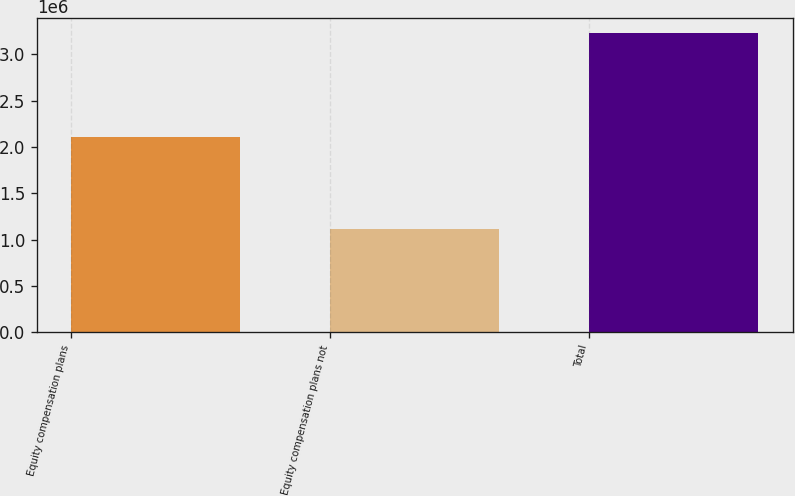Convert chart to OTSL. <chart><loc_0><loc_0><loc_500><loc_500><bar_chart><fcel>Equity compensation plans<fcel>Equity compensation plans not<fcel>Total<nl><fcel>2.11114e+06<fcel>1.11662e+06<fcel>3.22775e+06<nl></chart> 